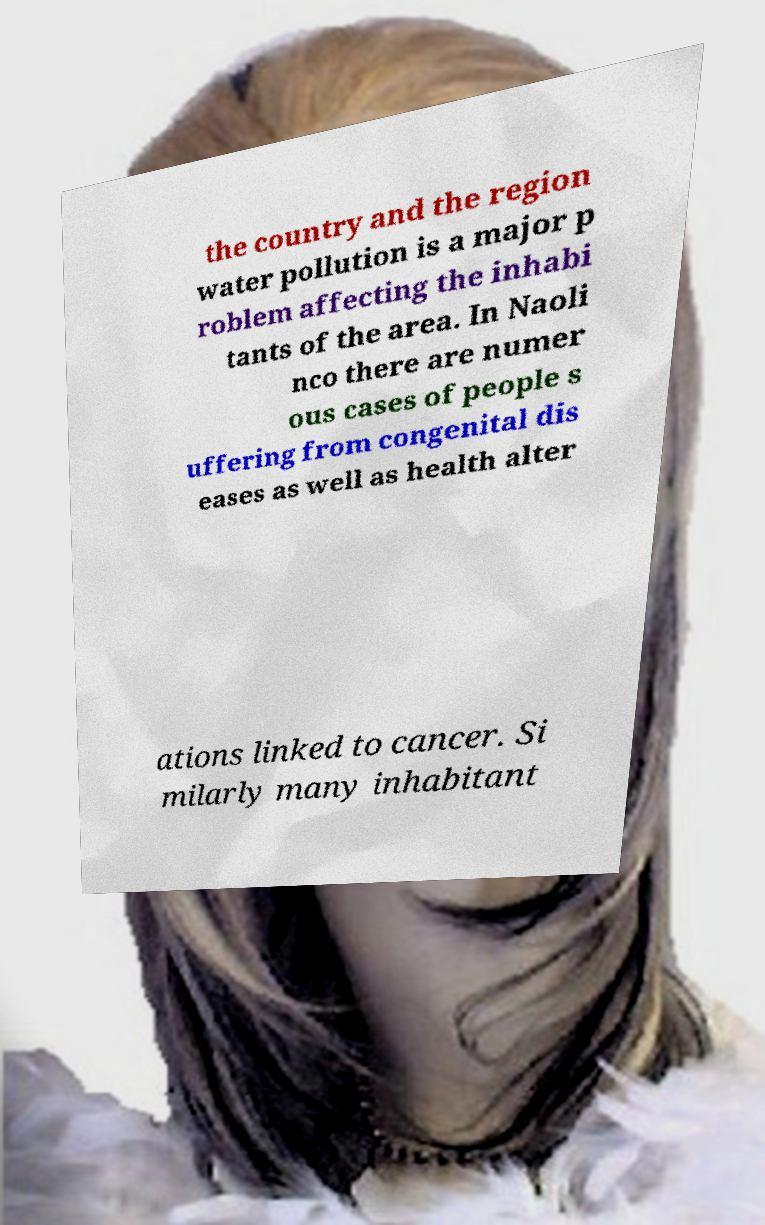Please read and relay the text visible in this image. What does it say? the country and the region water pollution is a major p roblem affecting the inhabi tants of the area. In Naoli nco there are numer ous cases of people s uffering from congenital dis eases as well as health alter ations linked to cancer. Si milarly many inhabitant 